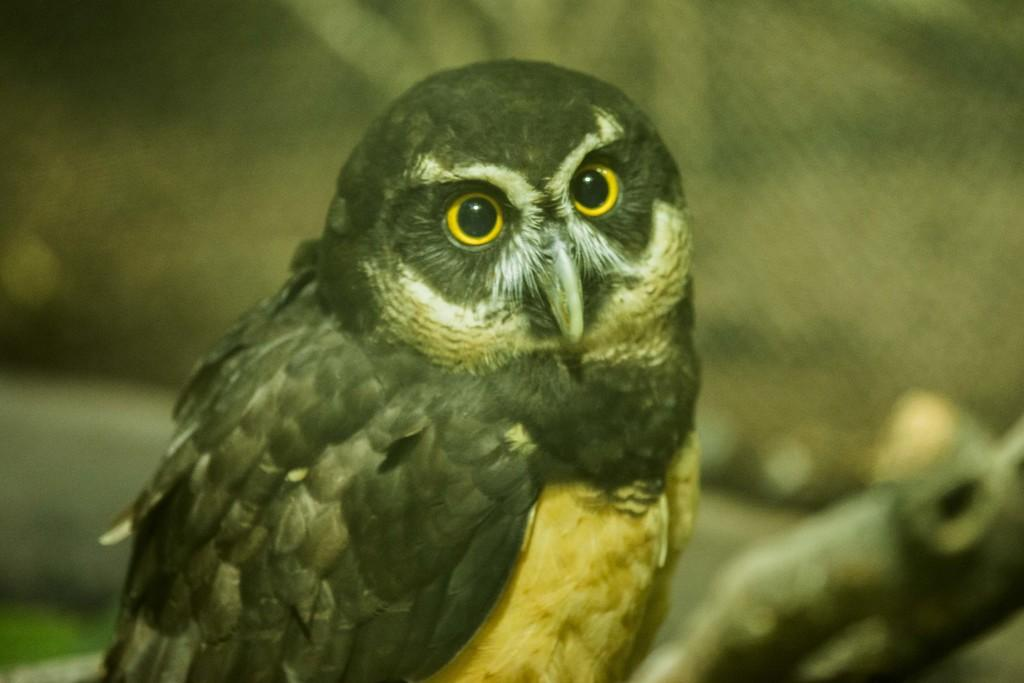What animal is the main subject of the picture? There is an owl in the picture. What colors can be seen in the owl's eyes? The owl's eyes are yellow and black in color. Can you describe the background of the image? The background of the image is blurry. What type of wax can be seen dripping from the branch in the image? There is no wax or branch present in the image; it features an owl with a blurry background. 